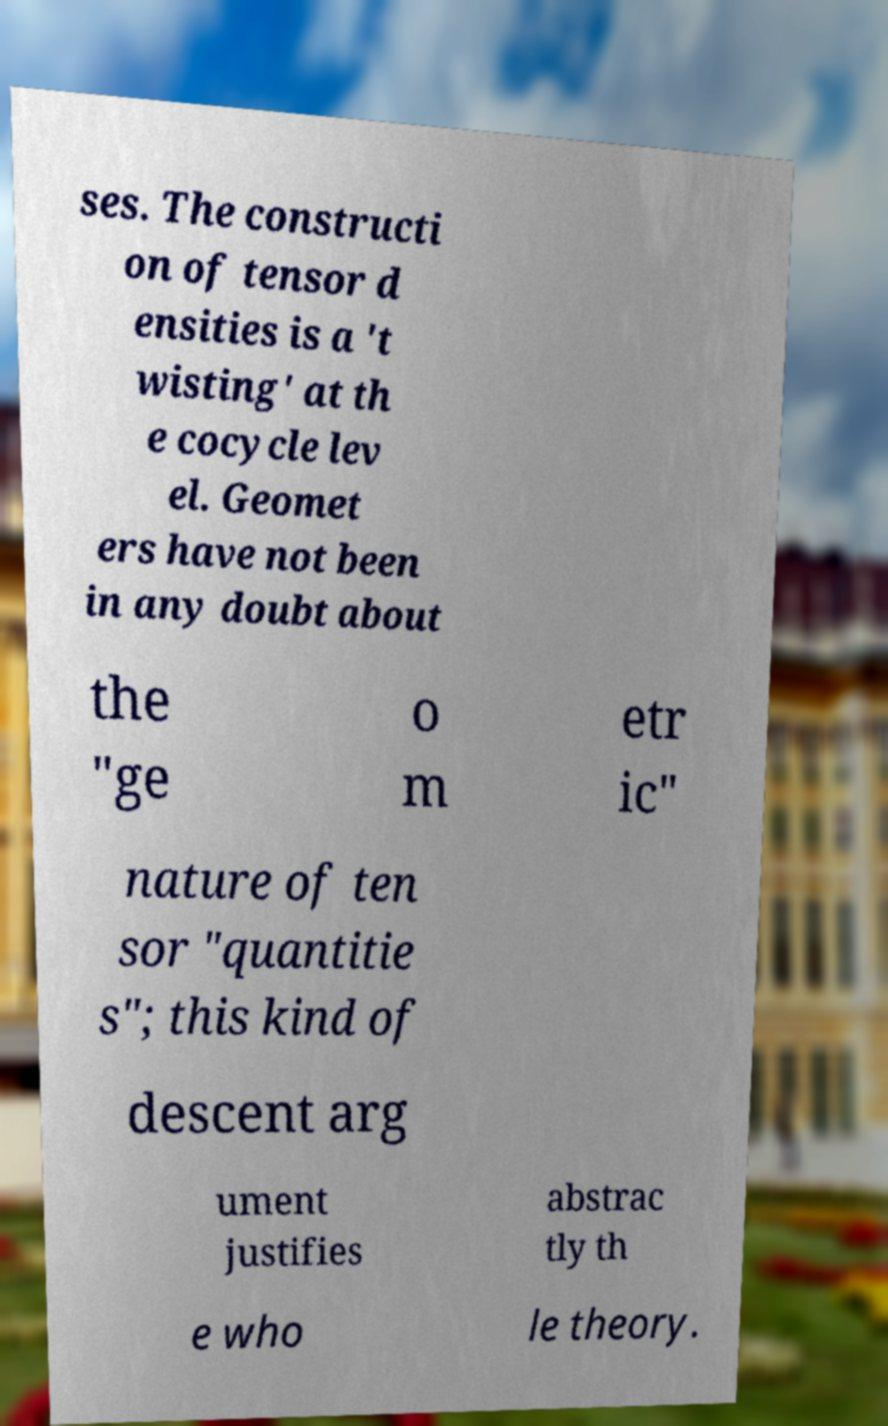Could you extract and type out the text from this image? ses. The constructi on of tensor d ensities is a 't wisting' at th e cocycle lev el. Geomet ers have not been in any doubt about the "ge o m etr ic" nature of ten sor "quantitie s"; this kind of descent arg ument justifies abstrac tly th e who le theory. 